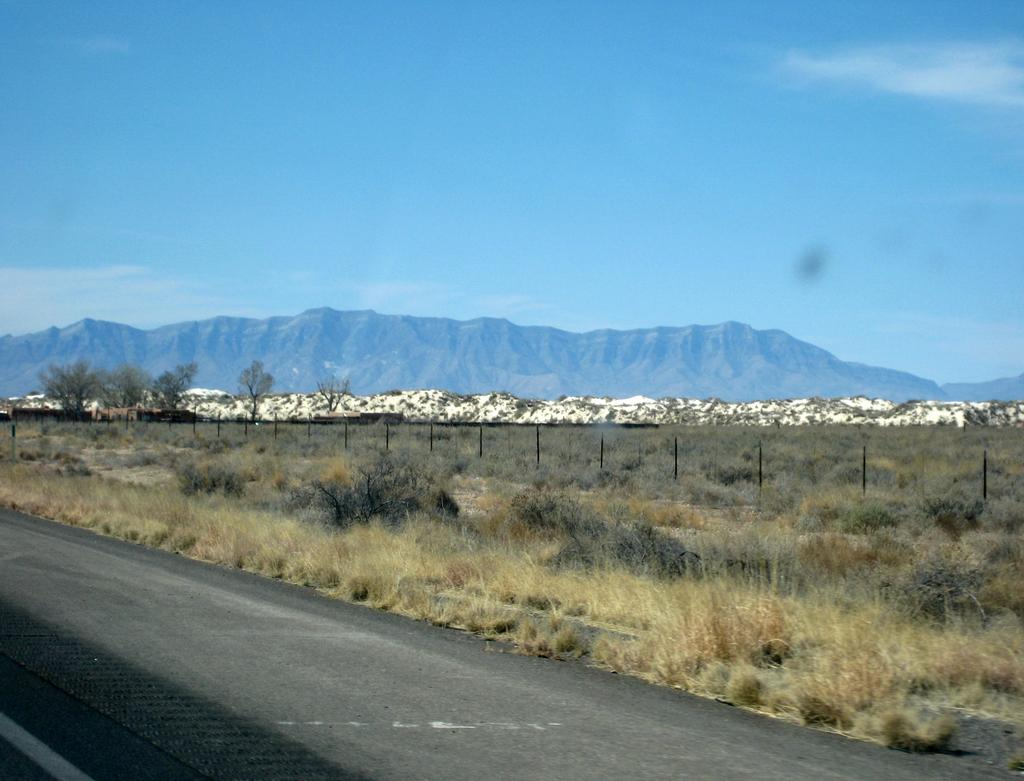What type of vegetation is present in the image? There is dry grass in the image. What type of structure can be seen in the image? There is fencing in the image. What other natural elements are visible in the image? There are trees and mountains in the image. What is the color of the sky in the image? The sky is a combination of white and blue colors. How many teeth can be seen in the image? There are no teeth present in the image. What type of footwear is visible on the people in the image? There are no people or footwear visible in the image. 